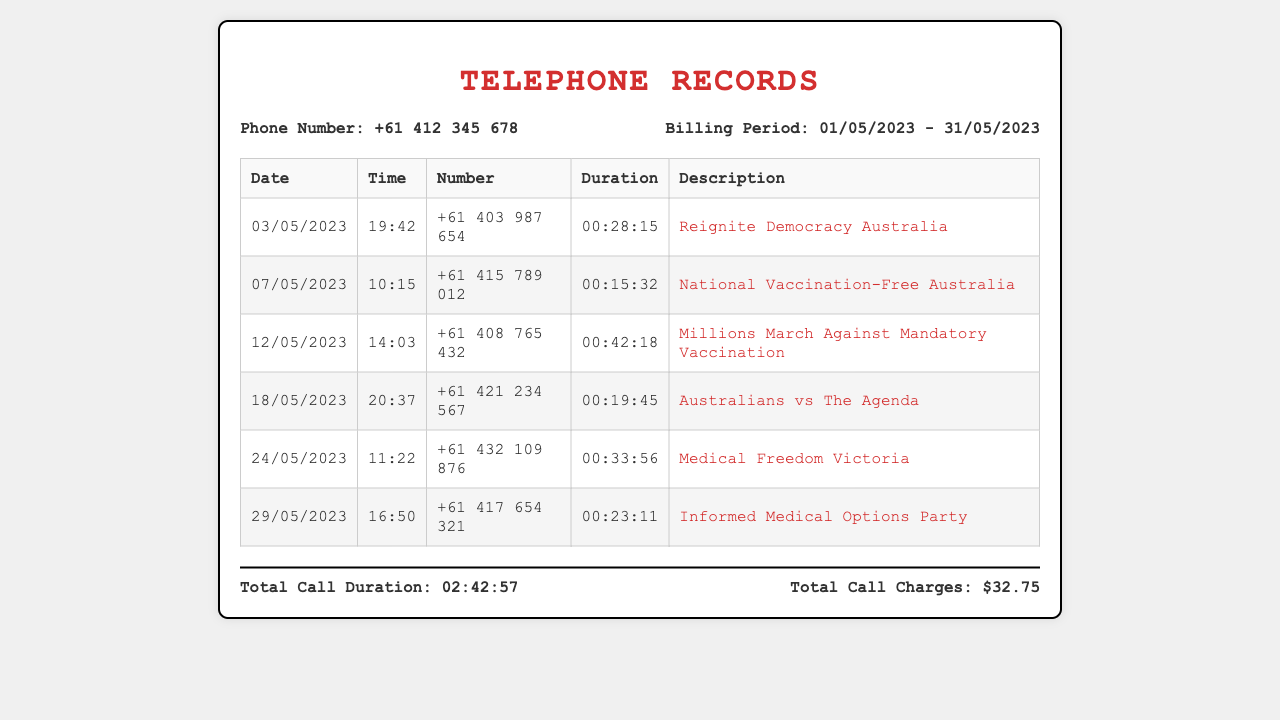what is the phone number in the records? The phone number is listed in the document under "Phone Number" section.
Answer: +61 412 345 678 what is the billing period? The billing period is specified in the document.
Answer: 01/05/2023 - 31/05/2023 which organization had the longest call duration? The longest call duration is found by comparing all durations in the table.
Answer: Millions March Against Mandatory Vaccination how many calls were made to organizations listed in the document? The total number of calls is counted from the entries in the table.
Answer: 6 what is the total call duration? The total call duration is provided at the end of the records section.
Answer: 02:42:57 when was the call to National Vaccination-Free Australia made? The date of the call is listed directly in the table for that organization.
Answer: 07/05/2023 what is the total amount charged for the calls? The total amount charged is specified in the document as part of the billing details.
Answer: $32.75 how many minutes did the call on 18/05/2023 last? The duration of this specific call is shown in the duration column for that date.
Answer: 19 minutes 45 seconds which organization was called on 29/05/2023? The specific organization for that date is mentioned in the description field of the table.
Answer: Informed Medical Options Party 